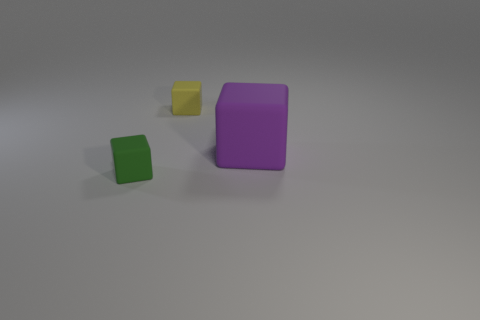What might the size difference in the objects suggest about how they could be used? The size difference indicates that the objects could serve varying purposes. The larger object could be used as a container or a standalone decorative piece, while the smaller ones might be part of a set or used to complement the larger object in an arrangement or as game pieces. 